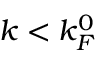<formula> <loc_0><loc_0><loc_500><loc_500>k < k _ { F } ^ { 0 }</formula> 